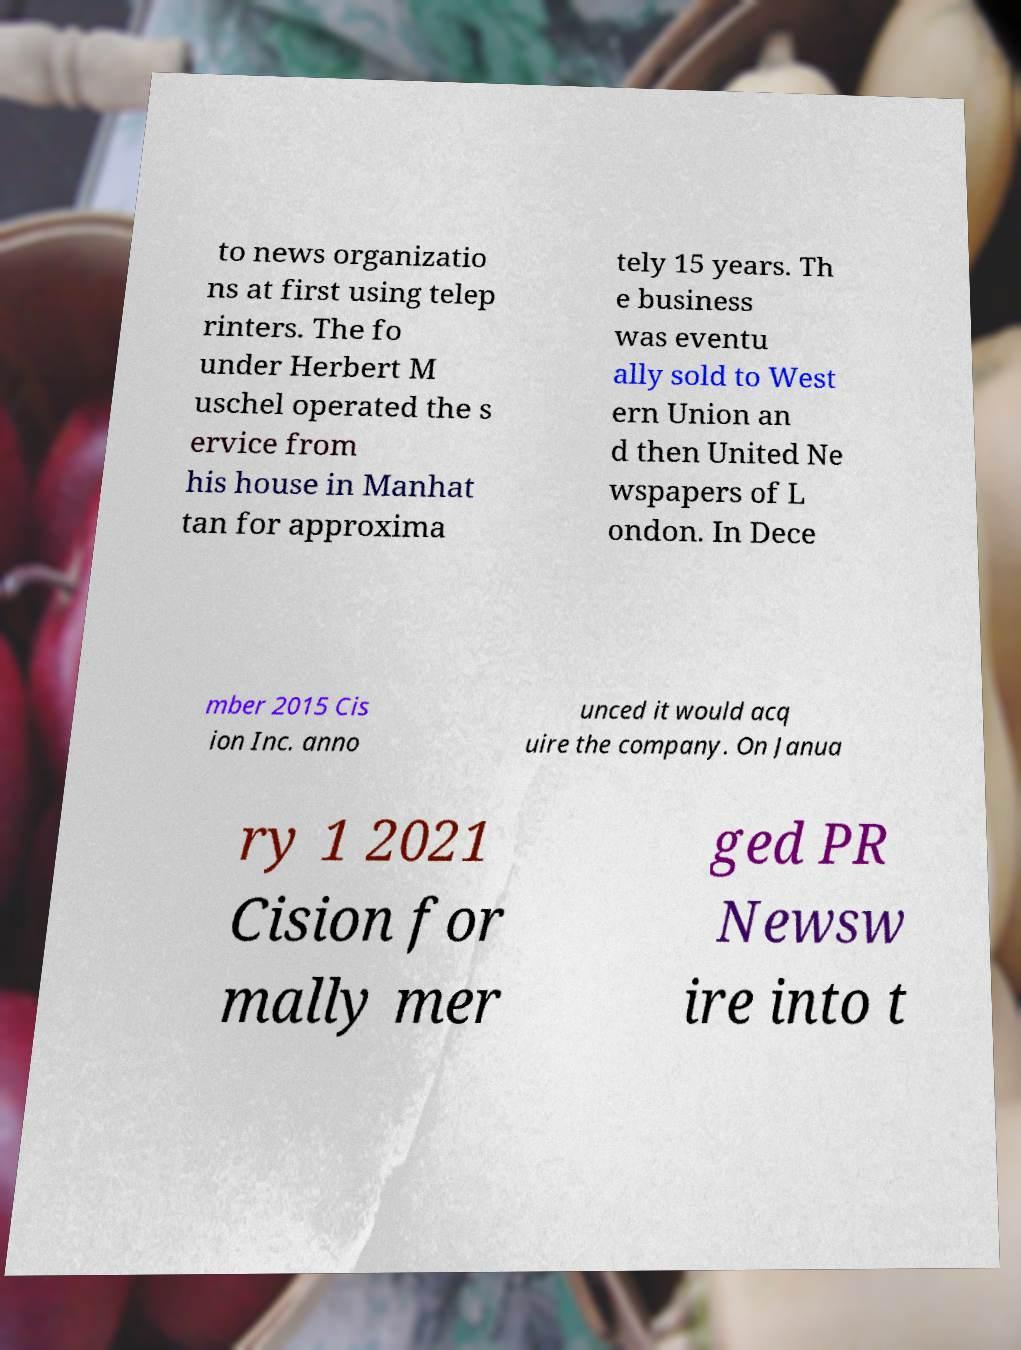I need the written content from this picture converted into text. Can you do that? to news organizatio ns at first using telep rinters. The fo under Herbert M uschel operated the s ervice from his house in Manhat tan for approxima tely 15 years. Th e business was eventu ally sold to West ern Union an d then United Ne wspapers of L ondon. In Dece mber 2015 Cis ion Inc. anno unced it would acq uire the company. On Janua ry 1 2021 Cision for mally mer ged PR Newsw ire into t 